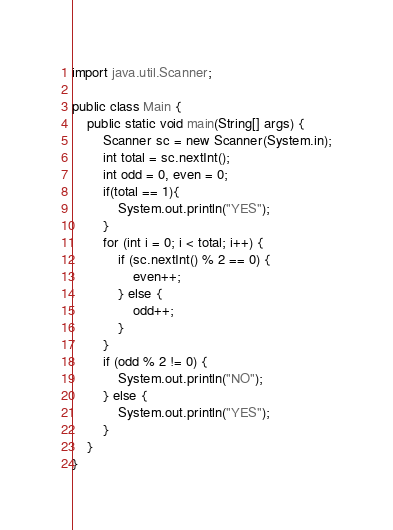Convert code to text. <code><loc_0><loc_0><loc_500><loc_500><_Java_>import java.util.Scanner;

public class Main {
	public static void main(String[] args) {
		Scanner sc = new Scanner(System.in);
		int total = sc.nextInt();
		int odd = 0, even = 0;
		if(total == 1){
			System.out.println("YES");
		}
		for (int i = 0; i < total; i++) {
			if (sc.nextInt() % 2 == 0) {
				even++;
			} else {
				odd++;
			}
		}
		if (odd % 2 != 0) {
			System.out.println("NO");
		} else {
			System.out.println("YES");
		}
	}
}</code> 